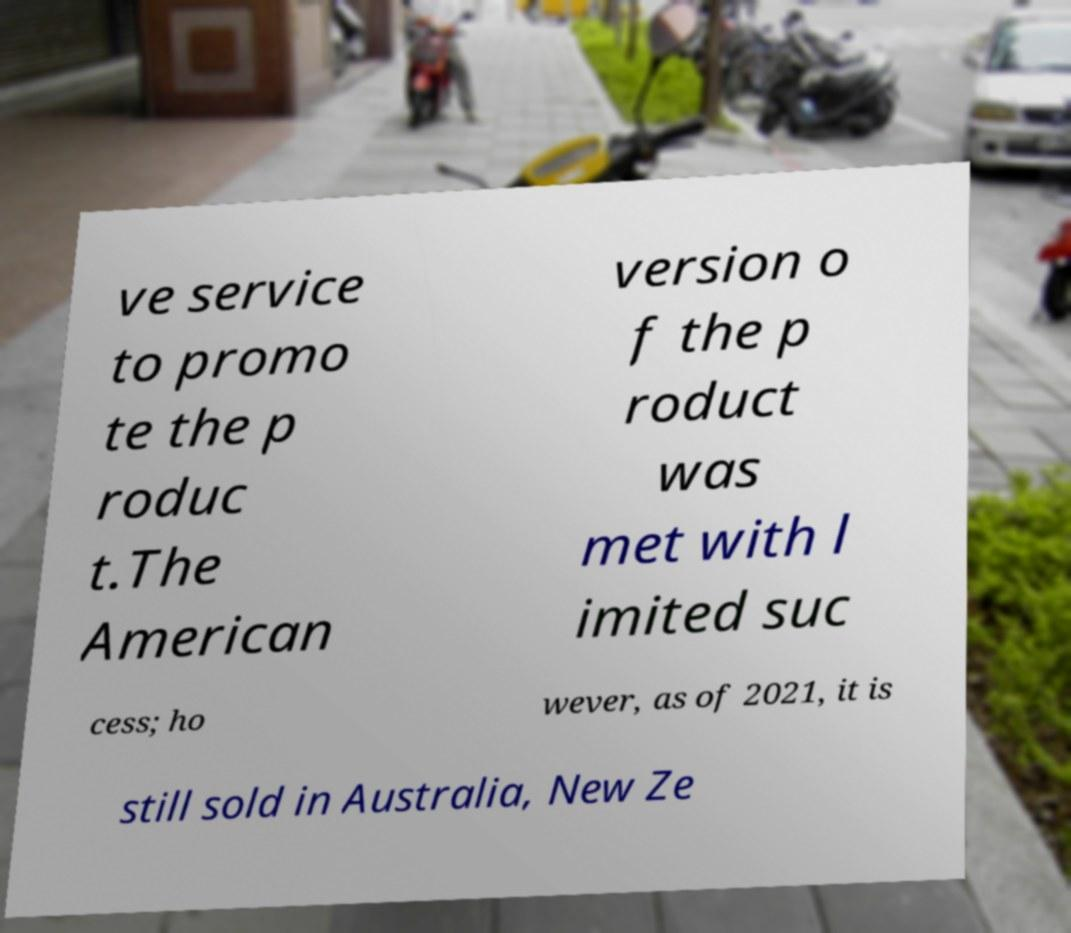Please read and relay the text visible in this image. What does it say? ve service to promo te the p roduc t.The American version o f the p roduct was met with l imited suc cess; ho wever, as of 2021, it is still sold in Australia, New Ze 